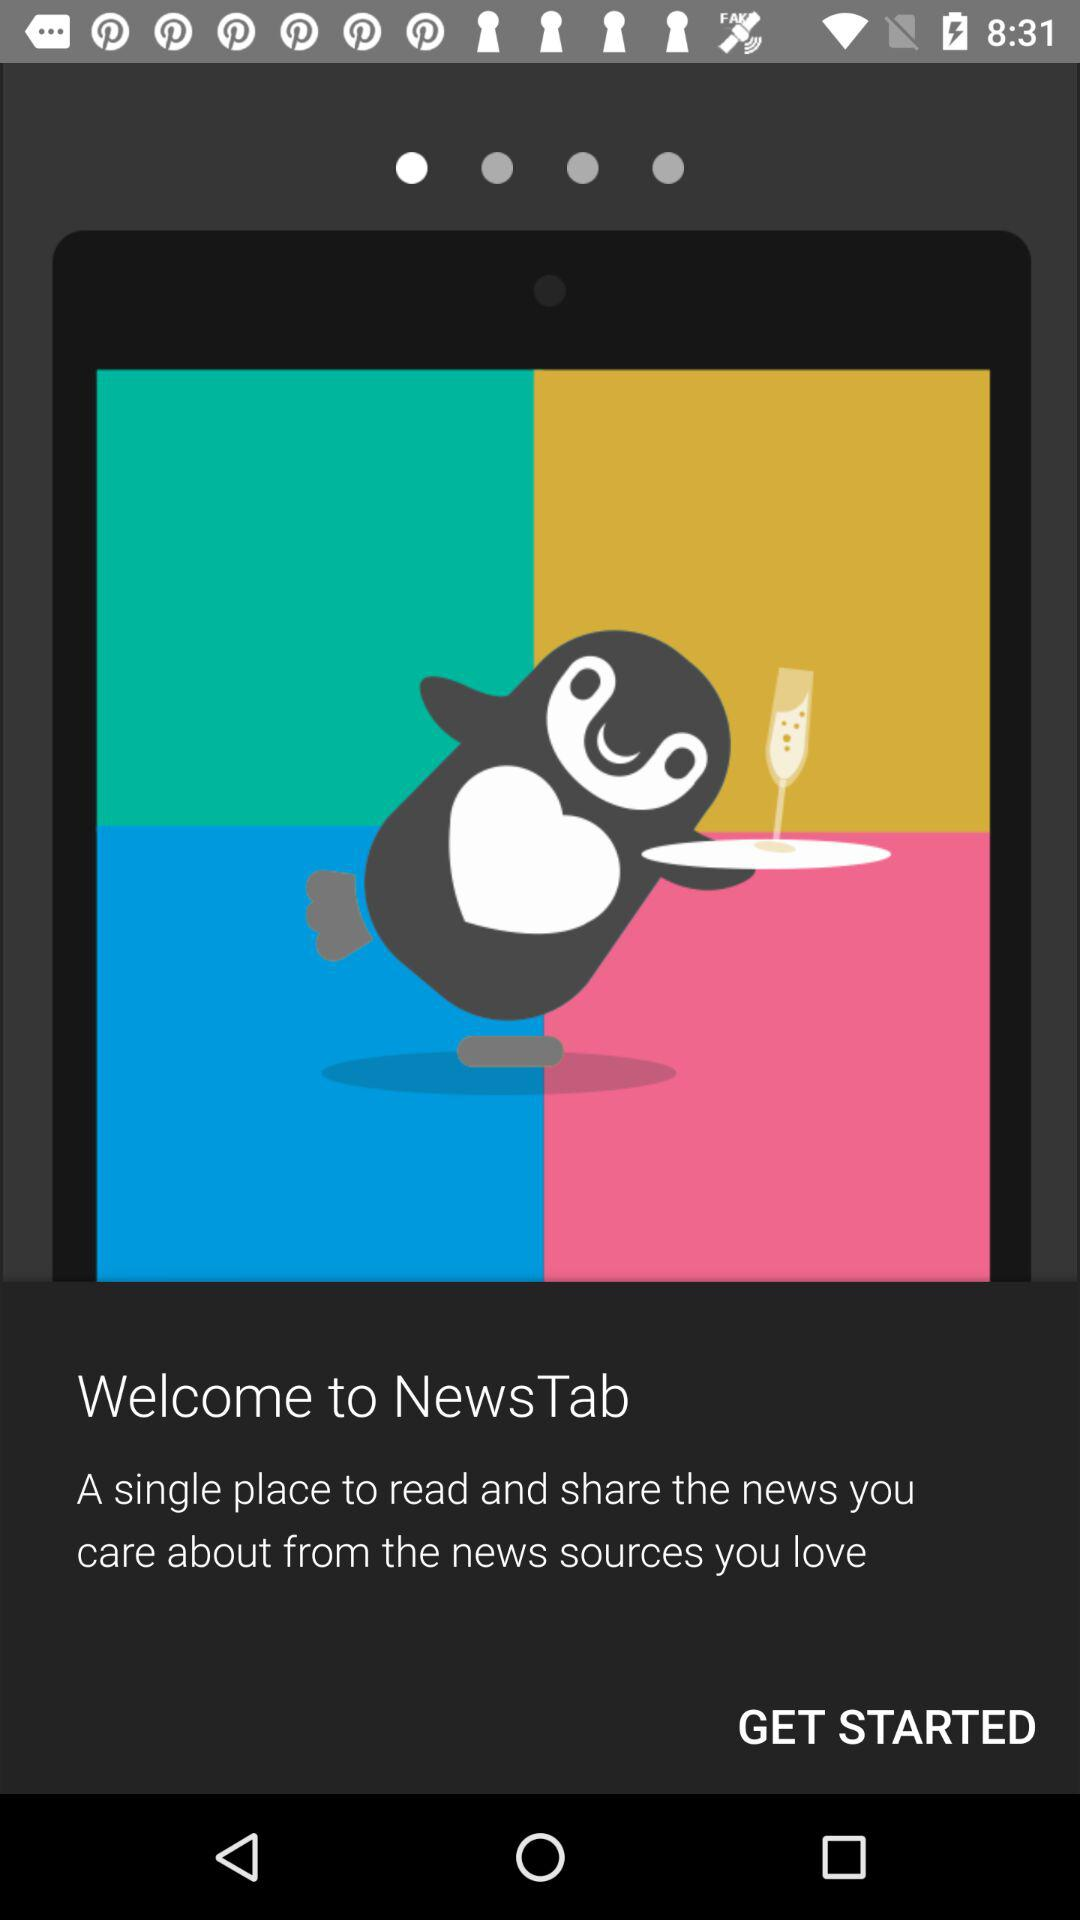What is the application name? The application name is "NewsTab". 